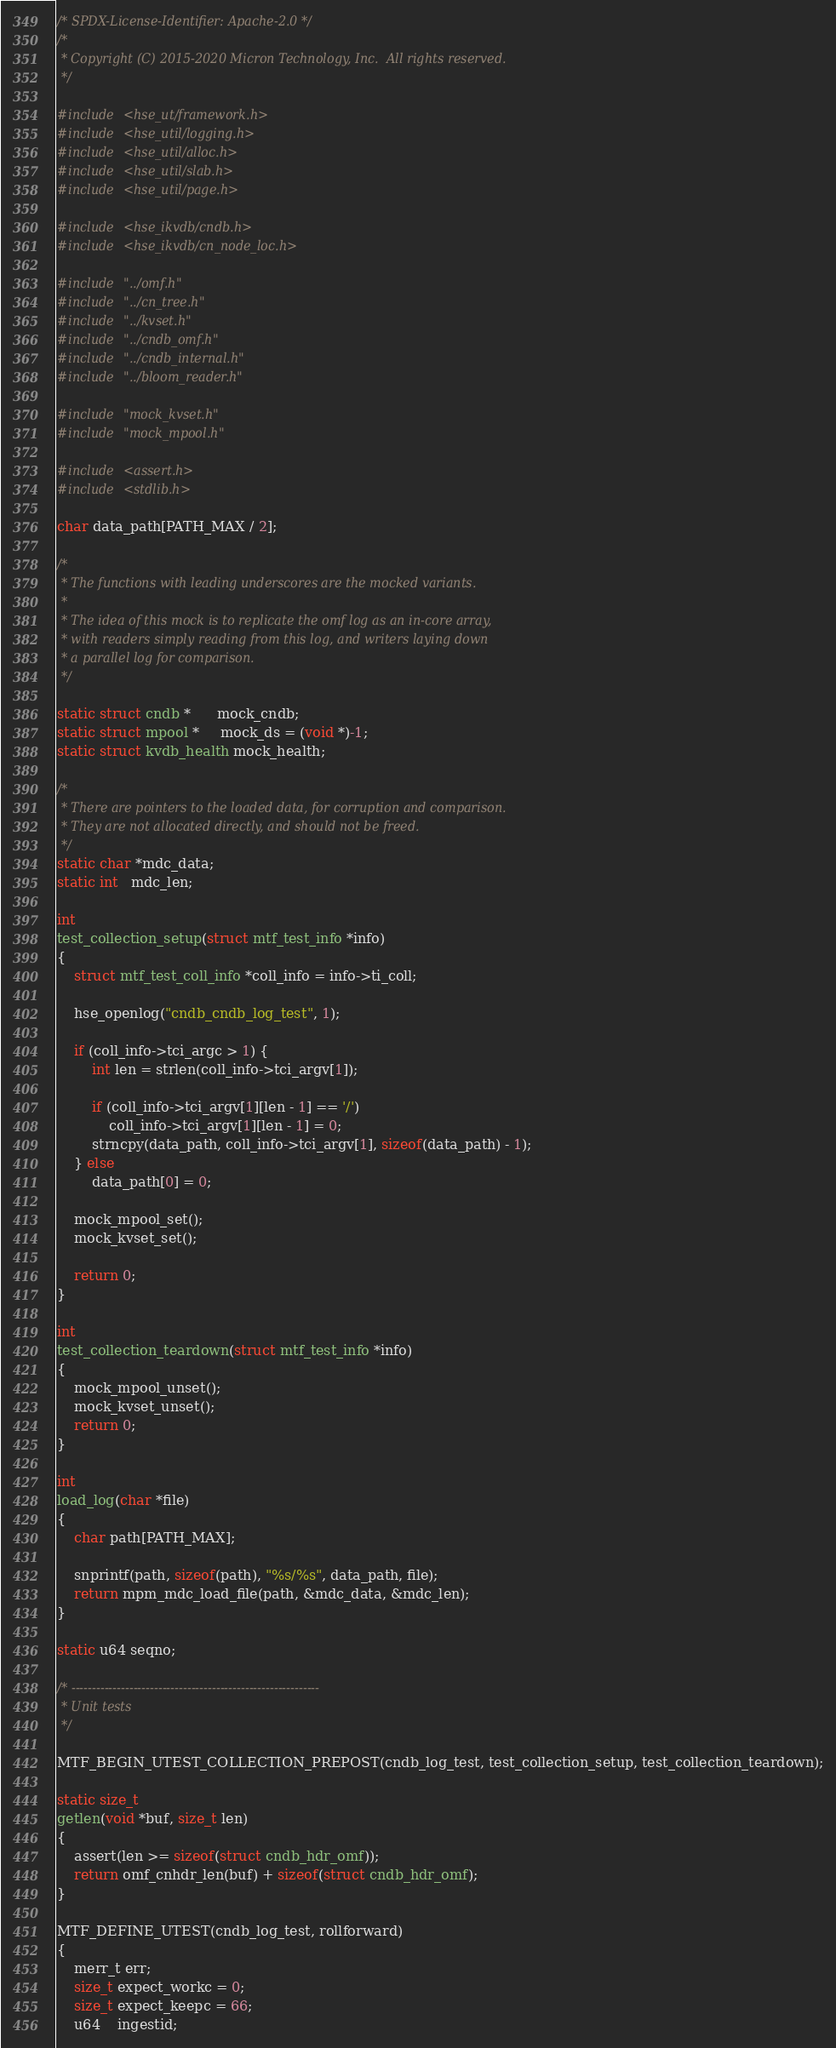Convert code to text. <code><loc_0><loc_0><loc_500><loc_500><_C_>/* SPDX-License-Identifier: Apache-2.0 */
/*
 * Copyright (C) 2015-2020 Micron Technology, Inc.  All rights reserved.
 */

#include <hse_ut/framework.h>
#include <hse_util/logging.h>
#include <hse_util/alloc.h>
#include <hse_util/slab.h>
#include <hse_util/page.h>

#include <hse_ikvdb/cndb.h>
#include <hse_ikvdb/cn_node_loc.h>

#include "../omf.h"
#include "../cn_tree.h"
#include "../kvset.h"
#include "../cndb_omf.h"
#include "../cndb_internal.h"
#include "../bloom_reader.h"

#include "mock_kvset.h"
#include "mock_mpool.h"

#include <assert.h>
#include <stdlib.h>

char data_path[PATH_MAX / 2];

/*
 * The functions with leading underscores are the mocked variants.
 *
 * The idea of this mock is to replicate the omf log as an in-core array,
 * with readers simply reading from this log, and writers laying down
 * a parallel log for comparison.
 */

static struct cndb *      mock_cndb;
static struct mpool *     mock_ds = (void *)-1;
static struct kvdb_health mock_health;

/*
 * There are pointers to the loaded data, for corruption and comparison.
 * They are not allocated directly, and should not be freed.
 */
static char *mdc_data;
static int   mdc_len;

int
test_collection_setup(struct mtf_test_info *info)
{
    struct mtf_test_coll_info *coll_info = info->ti_coll;

    hse_openlog("cndb_cndb_log_test", 1);

    if (coll_info->tci_argc > 1) {
        int len = strlen(coll_info->tci_argv[1]);

        if (coll_info->tci_argv[1][len - 1] == '/')
            coll_info->tci_argv[1][len - 1] = 0;
        strncpy(data_path, coll_info->tci_argv[1], sizeof(data_path) - 1);
    } else
        data_path[0] = 0;

    mock_mpool_set();
    mock_kvset_set();

    return 0;
}

int
test_collection_teardown(struct mtf_test_info *info)
{
    mock_mpool_unset();
    mock_kvset_unset();
    return 0;
}

int
load_log(char *file)
{
    char path[PATH_MAX];

    snprintf(path, sizeof(path), "%s/%s", data_path, file);
    return mpm_mdc_load_file(path, &mdc_data, &mdc_len);
}

static u64 seqno;

/* ------------------------------------------------------------
 * Unit tests
 */

MTF_BEGIN_UTEST_COLLECTION_PREPOST(cndb_log_test, test_collection_setup, test_collection_teardown);

static size_t
getlen(void *buf, size_t len)
{
    assert(len >= sizeof(struct cndb_hdr_omf));
    return omf_cnhdr_len(buf) + sizeof(struct cndb_hdr_omf);
}

MTF_DEFINE_UTEST(cndb_log_test, rollforward)
{
    merr_t err;
    size_t expect_workc = 0;
    size_t expect_keepc = 66;
    u64    ingestid;
</code> 